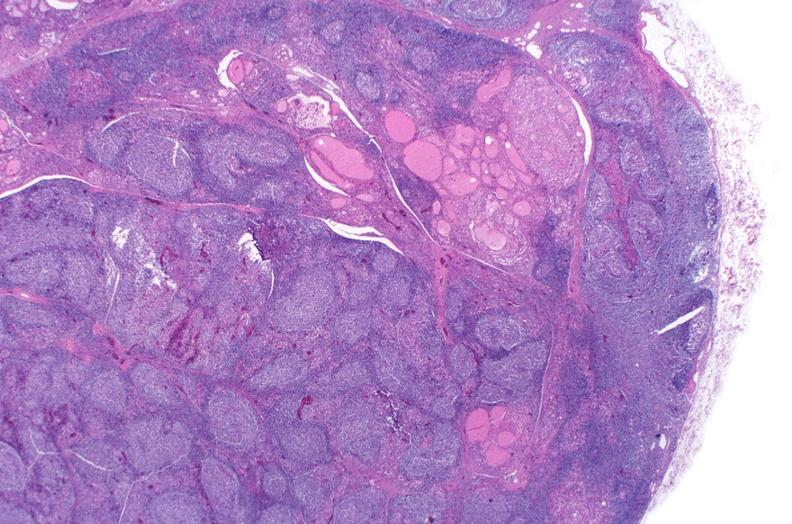does this image show hashimoto 's thyroiditis?
Answer the question using a single word or phrase. Yes 